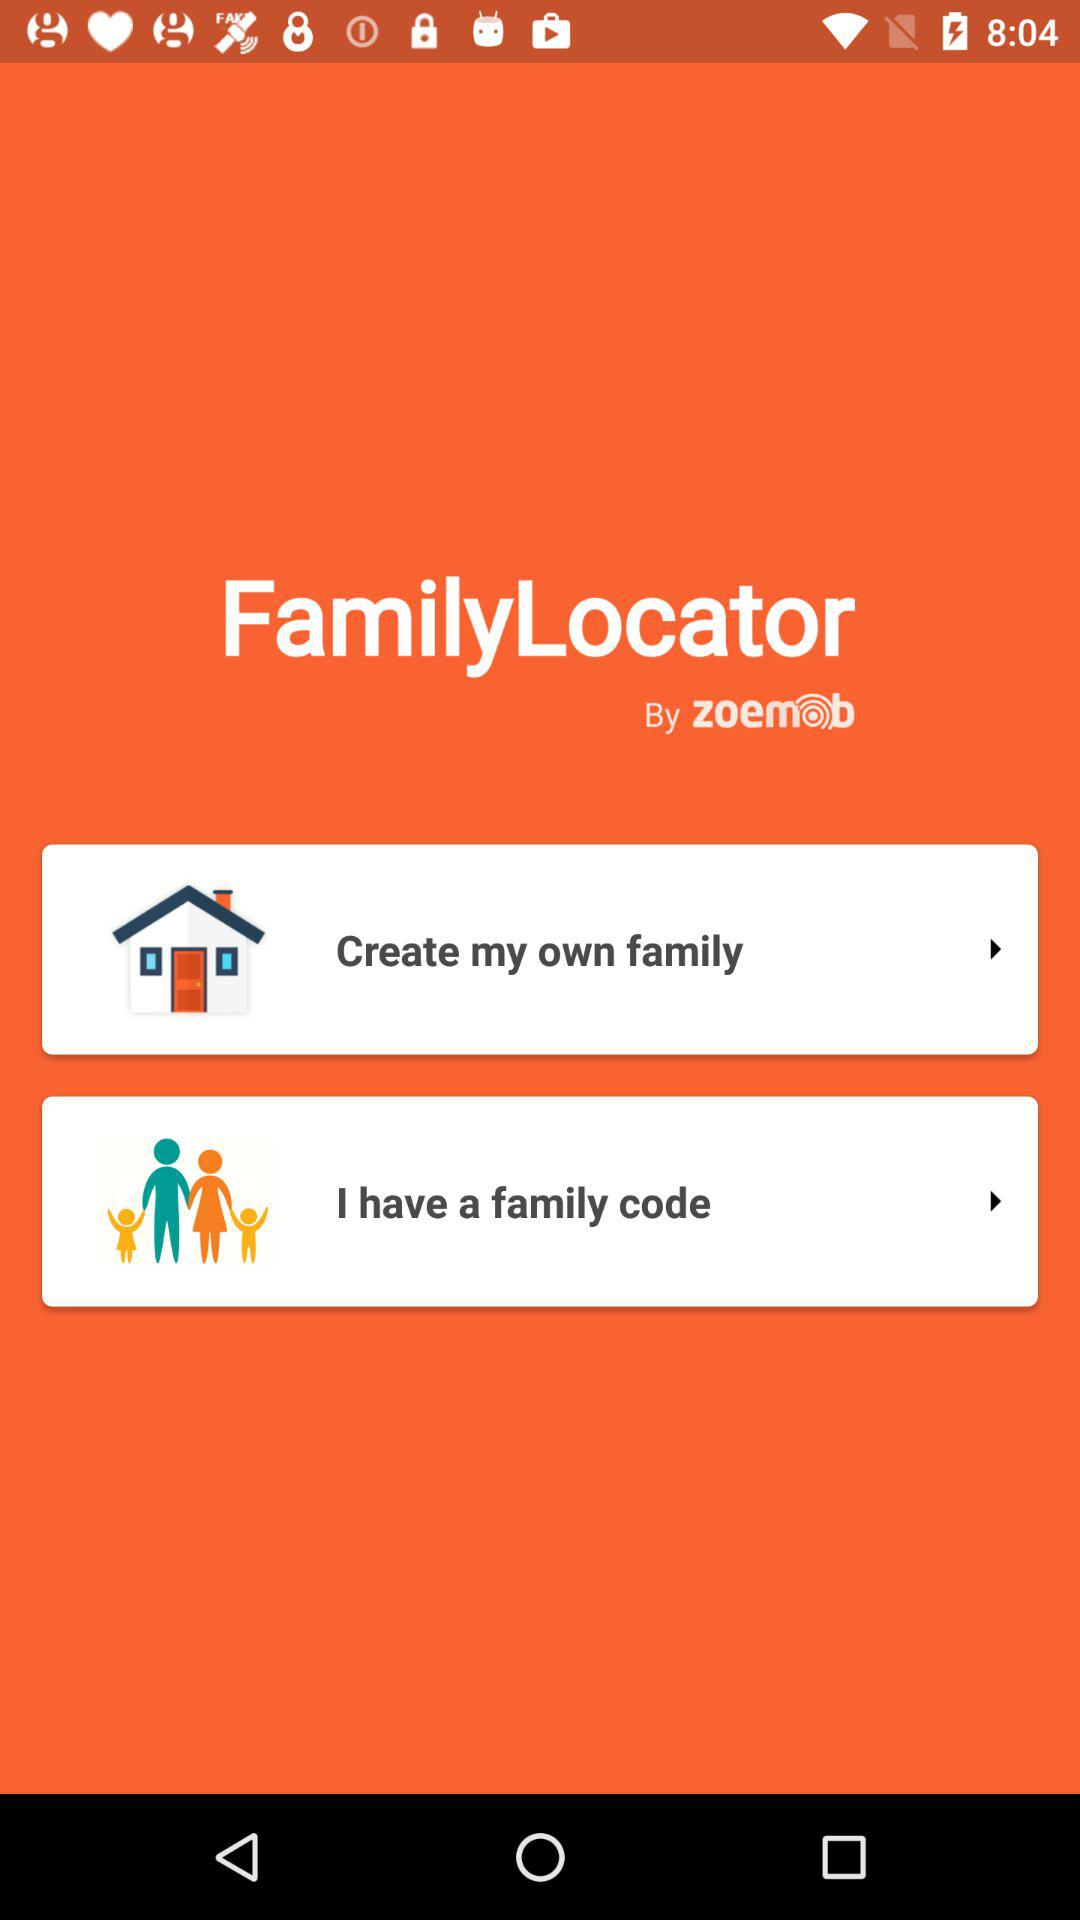By whom was the "FamilyLocator" app developed? The "FamilyLocator" app was developed by "zoemob". 